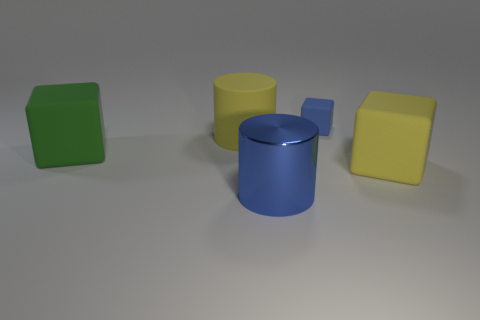Add 5 large matte blocks. How many objects exist? 10 Add 5 big blue cylinders. How many big blue cylinders exist? 6 Subtract all blue cylinders. How many cylinders are left? 1 Subtract all big cubes. How many cubes are left? 1 Subtract 0 purple cubes. How many objects are left? 5 Subtract all blocks. How many objects are left? 2 Subtract 2 cylinders. How many cylinders are left? 0 Subtract all red blocks. Subtract all green spheres. How many blocks are left? 3 Subtract all brown spheres. How many brown cylinders are left? 0 Subtract all big yellow matte blocks. Subtract all yellow rubber blocks. How many objects are left? 3 